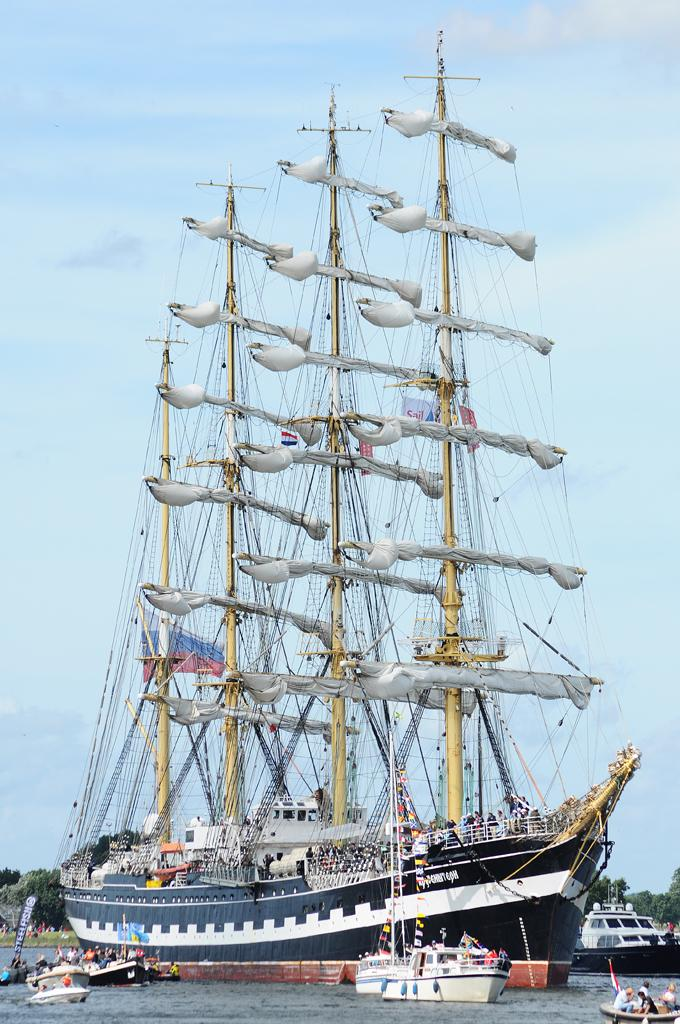<image>
Give a short and clear explanation of the subsequent image. An old sailing ship has smaller boats around it and one of them says Steelfish. 